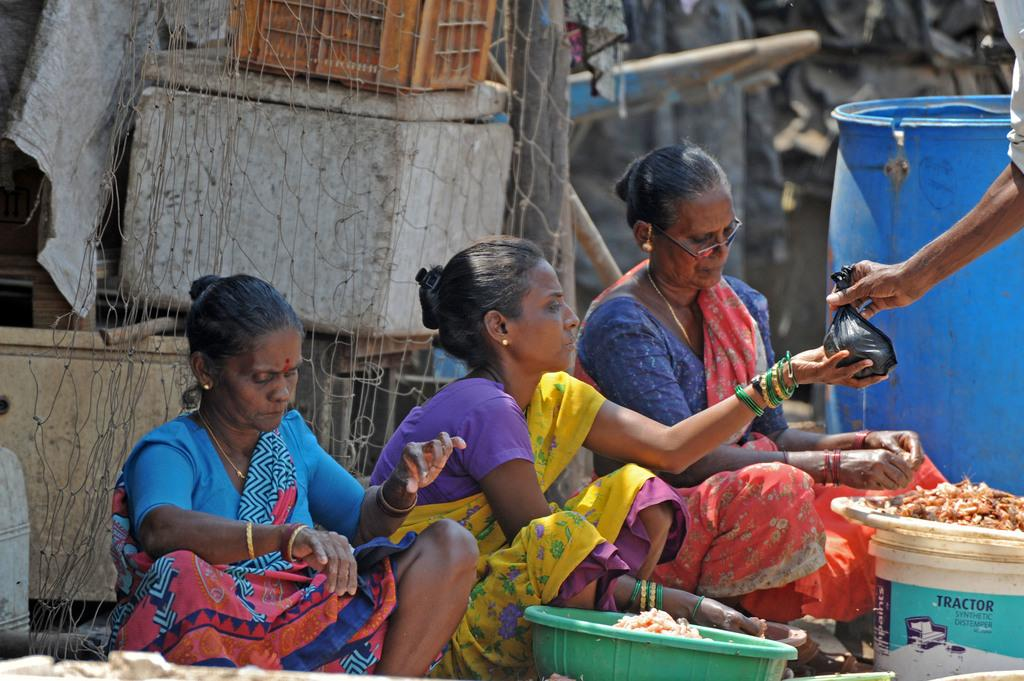How many people are in the image? There are people in the image, but the exact number is not specified. What musical instrument can be seen in the image? There is a drum in the image. What type of container is present in the image? There is a basket, a box, a container, and a bucket in the image. What material is used to create the mesh in the image? The material used to create the mesh in the image is not specified. What is the person holding in the image? A person is holding a plastic bag in the image. What can be said about the background of the image? The background of the image is blurred. What type of support does the carpenter need to fix the power lines in the image? There is no carpenter or power lines present in the image. 